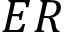Convert formula to latex. <formula><loc_0><loc_0><loc_500><loc_500>E R</formula> 